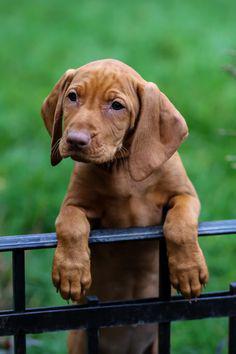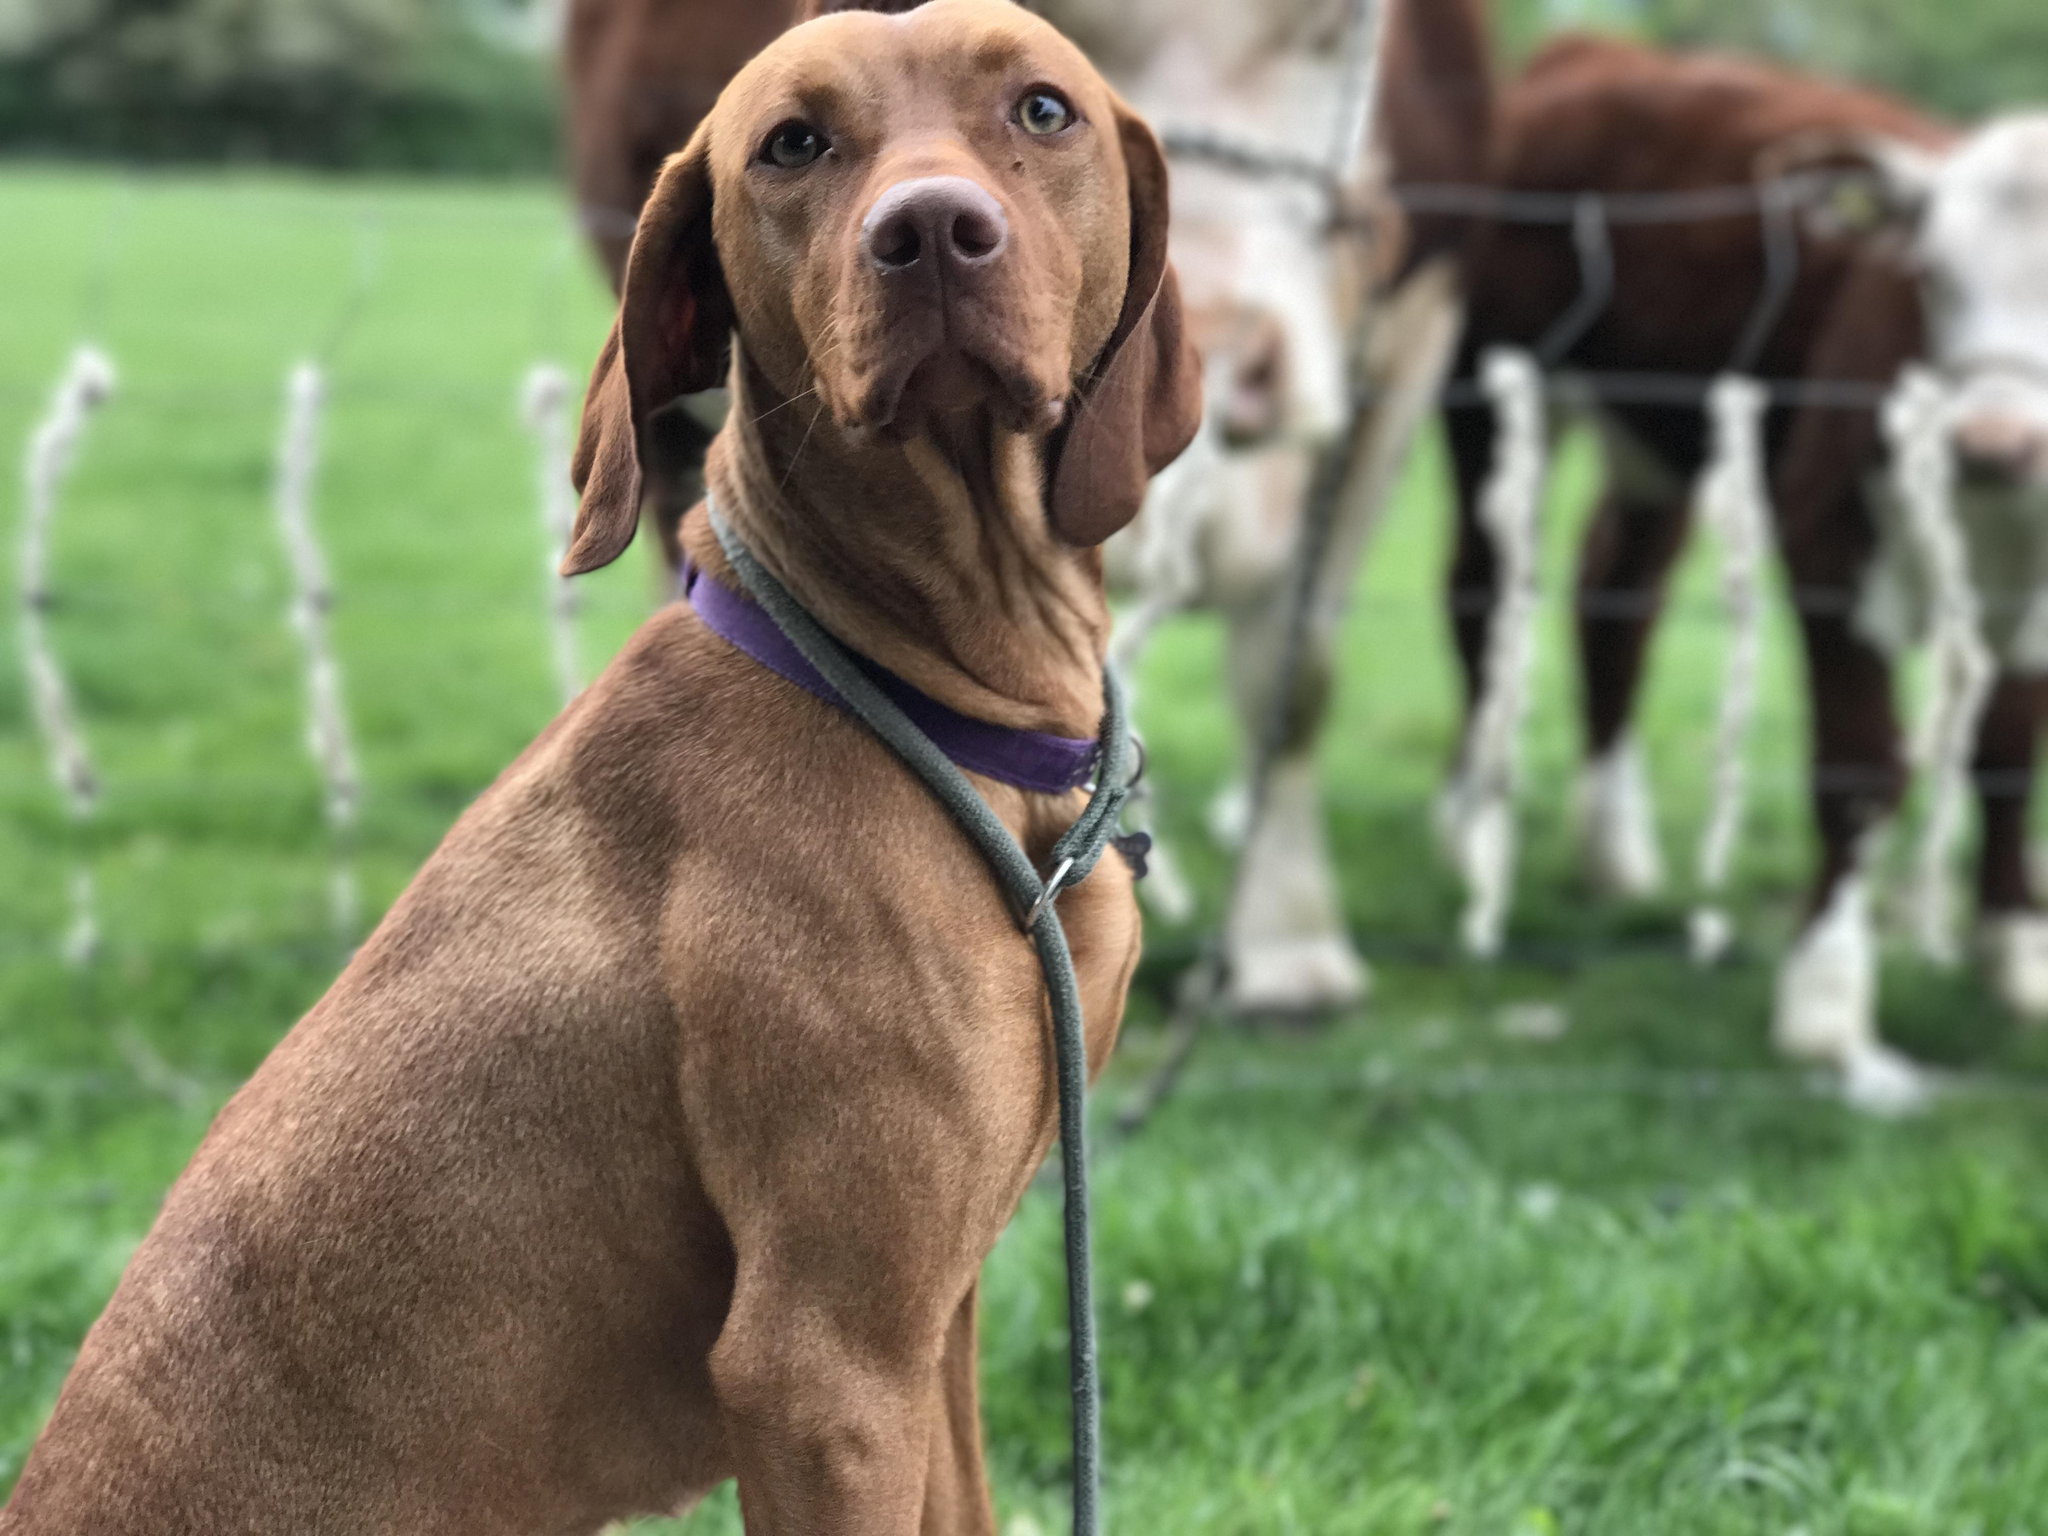The first image is the image on the left, the second image is the image on the right. Examine the images to the left and right. Is the description "A dog is wearing a collar." accurate? Answer yes or no. Yes. The first image is the image on the left, the second image is the image on the right. For the images displayed, is the sentence "The right image features one camera-gazing puppy with fully open eyes, and the left image features one reclining puppy with its front paws forward." factually correct? Answer yes or no. No. 